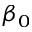<formula> <loc_0><loc_0><loc_500><loc_500>\beta _ { 0 }</formula> 